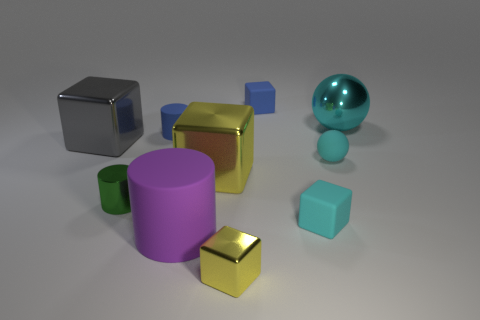There is a shiny object that is to the right of the cyan cube; is it the same size as the green metallic object?
Give a very brief answer. No. What number of things are either matte things to the left of the large purple matte thing or tiny matte cylinders that are behind the purple matte cylinder?
Give a very brief answer. 1. There is a ball that is in front of the large gray cube; does it have the same color as the metal ball?
Your response must be concise. Yes. What number of metal objects are either tiny cylinders or big balls?
Your answer should be compact. 2. The big purple matte object is what shape?
Make the answer very short. Cylinder. Are the tiny blue cylinder and the small sphere made of the same material?
Provide a short and direct response. Yes. There is a small matte cube to the right of the tiny rubber cube on the left side of the cyan block; are there any small blue cubes in front of it?
Your answer should be very brief. No. What number of other things are the same shape as the large matte thing?
Offer a terse response. 2. The large thing that is to the left of the cyan cube and on the right side of the large cylinder has what shape?
Provide a succinct answer. Cube. The large metal thing behind the small blue object that is left of the tiny cube that is behind the cyan metallic thing is what color?
Ensure brevity in your answer.  Cyan. 